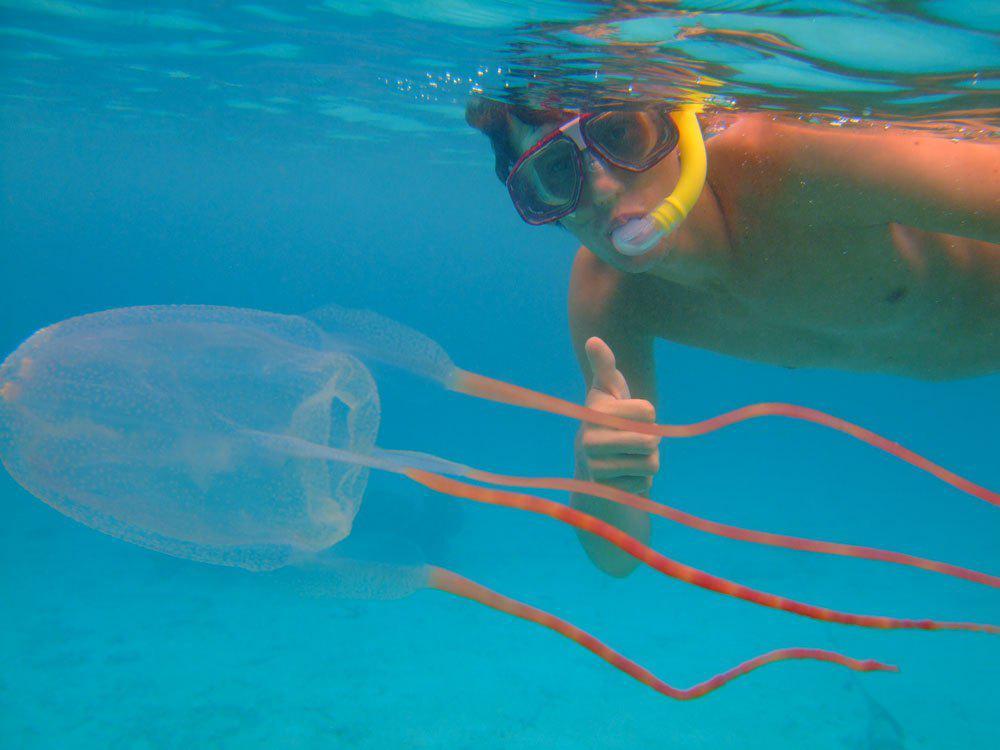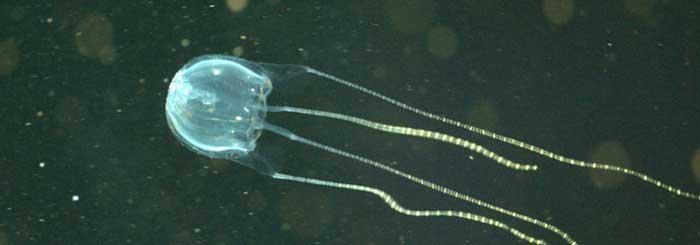The first image is the image on the left, the second image is the image on the right. Examine the images to the left and right. Is the description "Left image includes a diver wearing goggles." accurate? Answer yes or no. Yes. The first image is the image on the left, the second image is the image on the right. For the images shown, is this caption "There is scuba diver in the image on the right." true? Answer yes or no. No. 